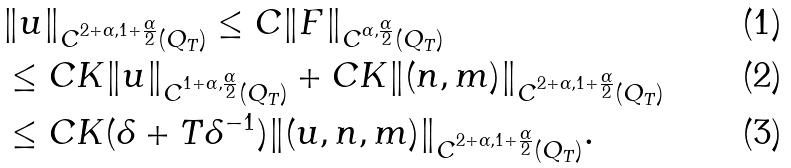<formula> <loc_0><loc_0><loc_500><loc_500>& \| { u } \| _ { C ^ { 2 + \alpha , 1 + \frac { \alpha } { 2 } } ( Q _ { T } ) } \leq C \| { F } \| _ { C ^ { \alpha , \frac { \alpha } { 2 } } ( Q _ { T } ) } \\ & \leq C K \| u \| _ { C ^ { 1 + \alpha , \frac { \alpha } 2 } ( Q _ { T } ) } + C K \| ( n , m ) \| _ { C ^ { 2 + \alpha , 1 + \frac { \alpha } 2 } ( Q _ { T } ) } \\ & \leq C K ( \delta + T \delta ^ { - 1 } ) \| ( u , n , m ) \| _ { C ^ { 2 + \alpha , 1 + \frac { \alpha } { 2 } } ( Q _ { T } ) } .</formula> 